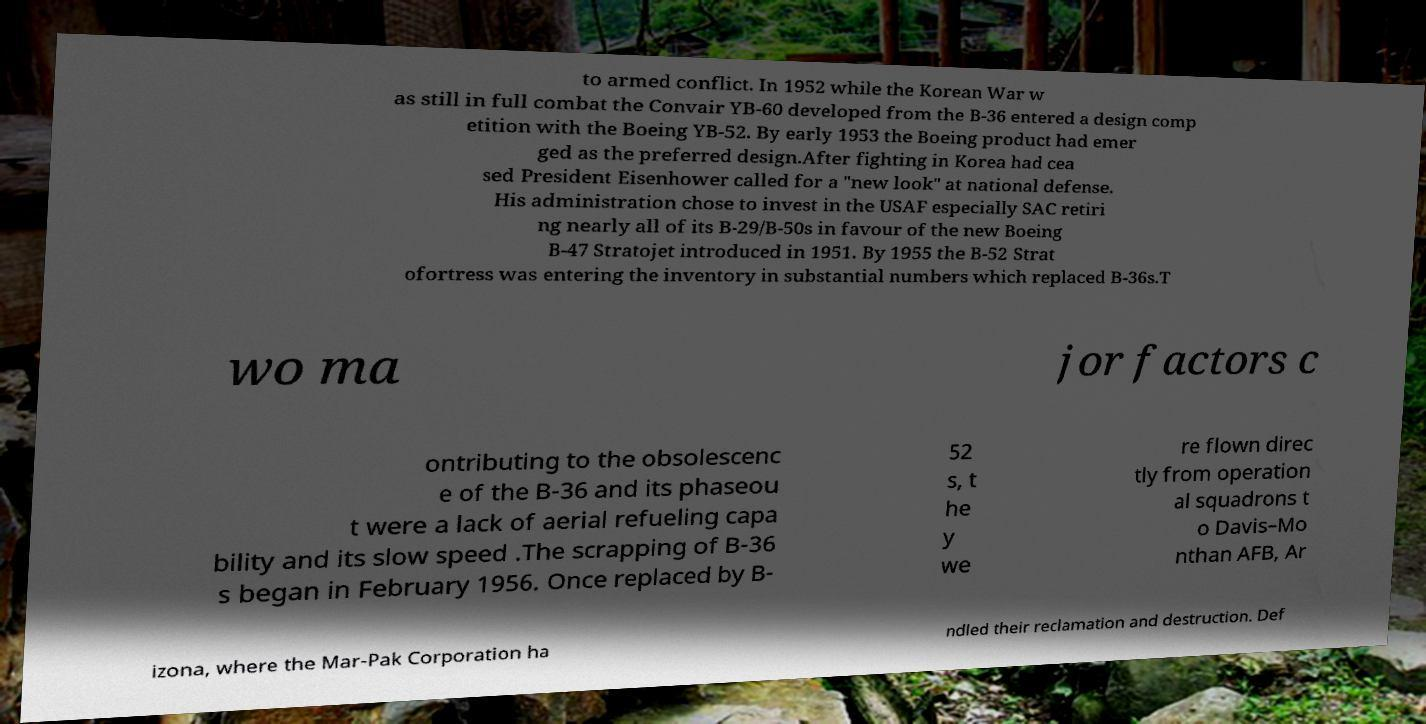For documentation purposes, I need the text within this image transcribed. Could you provide that? to armed conflict. In 1952 while the Korean War w as still in full combat the Convair YB-60 developed from the B-36 entered a design comp etition with the Boeing YB-52. By early 1953 the Boeing product had emer ged as the preferred design.After fighting in Korea had cea sed President Eisenhower called for a "new look" at national defense. His administration chose to invest in the USAF especially SAC retiri ng nearly all of its B-29/B-50s in favour of the new Boeing B-47 Stratojet introduced in 1951. By 1955 the B-52 Strat ofortress was entering the inventory in substantial numbers which replaced B-36s.T wo ma jor factors c ontributing to the obsolescenc e of the B-36 and its phaseou t were a lack of aerial refueling capa bility and its slow speed .The scrapping of B-36 s began in February 1956. Once replaced by B- 52 s, t he y we re flown direc tly from operation al squadrons t o Davis–Mo nthan AFB, Ar izona, where the Mar-Pak Corporation ha ndled their reclamation and destruction. Def 